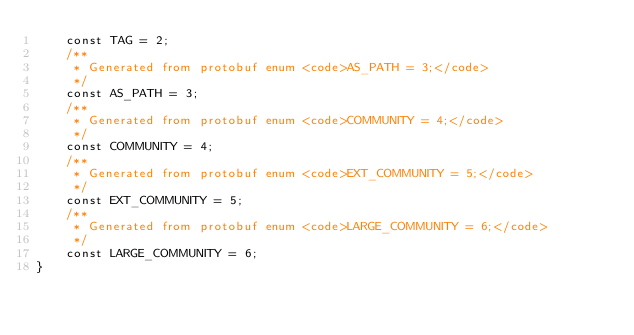Convert code to text. <code><loc_0><loc_0><loc_500><loc_500><_PHP_>	const TAG = 2;
	/**
	 * Generated from protobuf enum <code>AS_PATH = 3;</code>
	 */
	const AS_PATH = 3;
	/**
	 * Generated from protobuf enum <code>COMMUNITY = 4;</code>
	 */
	const COMMUNITY = 4;
	/**
	 * Generated from protobuf enum <code>EXT_COMMUNITY = 5;</code>
	 */
	const EXT_COMMUNITY = 5;
	/**
	 * Generated from protobuf enum <code>LARGE_COMMUNITY = 6;</code>
	 */
	const LARGE_COMMUNITY = 6;
}

</code> 